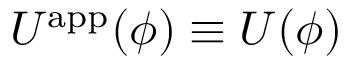<formula> <loc_0><loc_0><loc_500><loc_500>U ^ { a p p } ( \phi ) \equiv U ( \phi )</formula> 